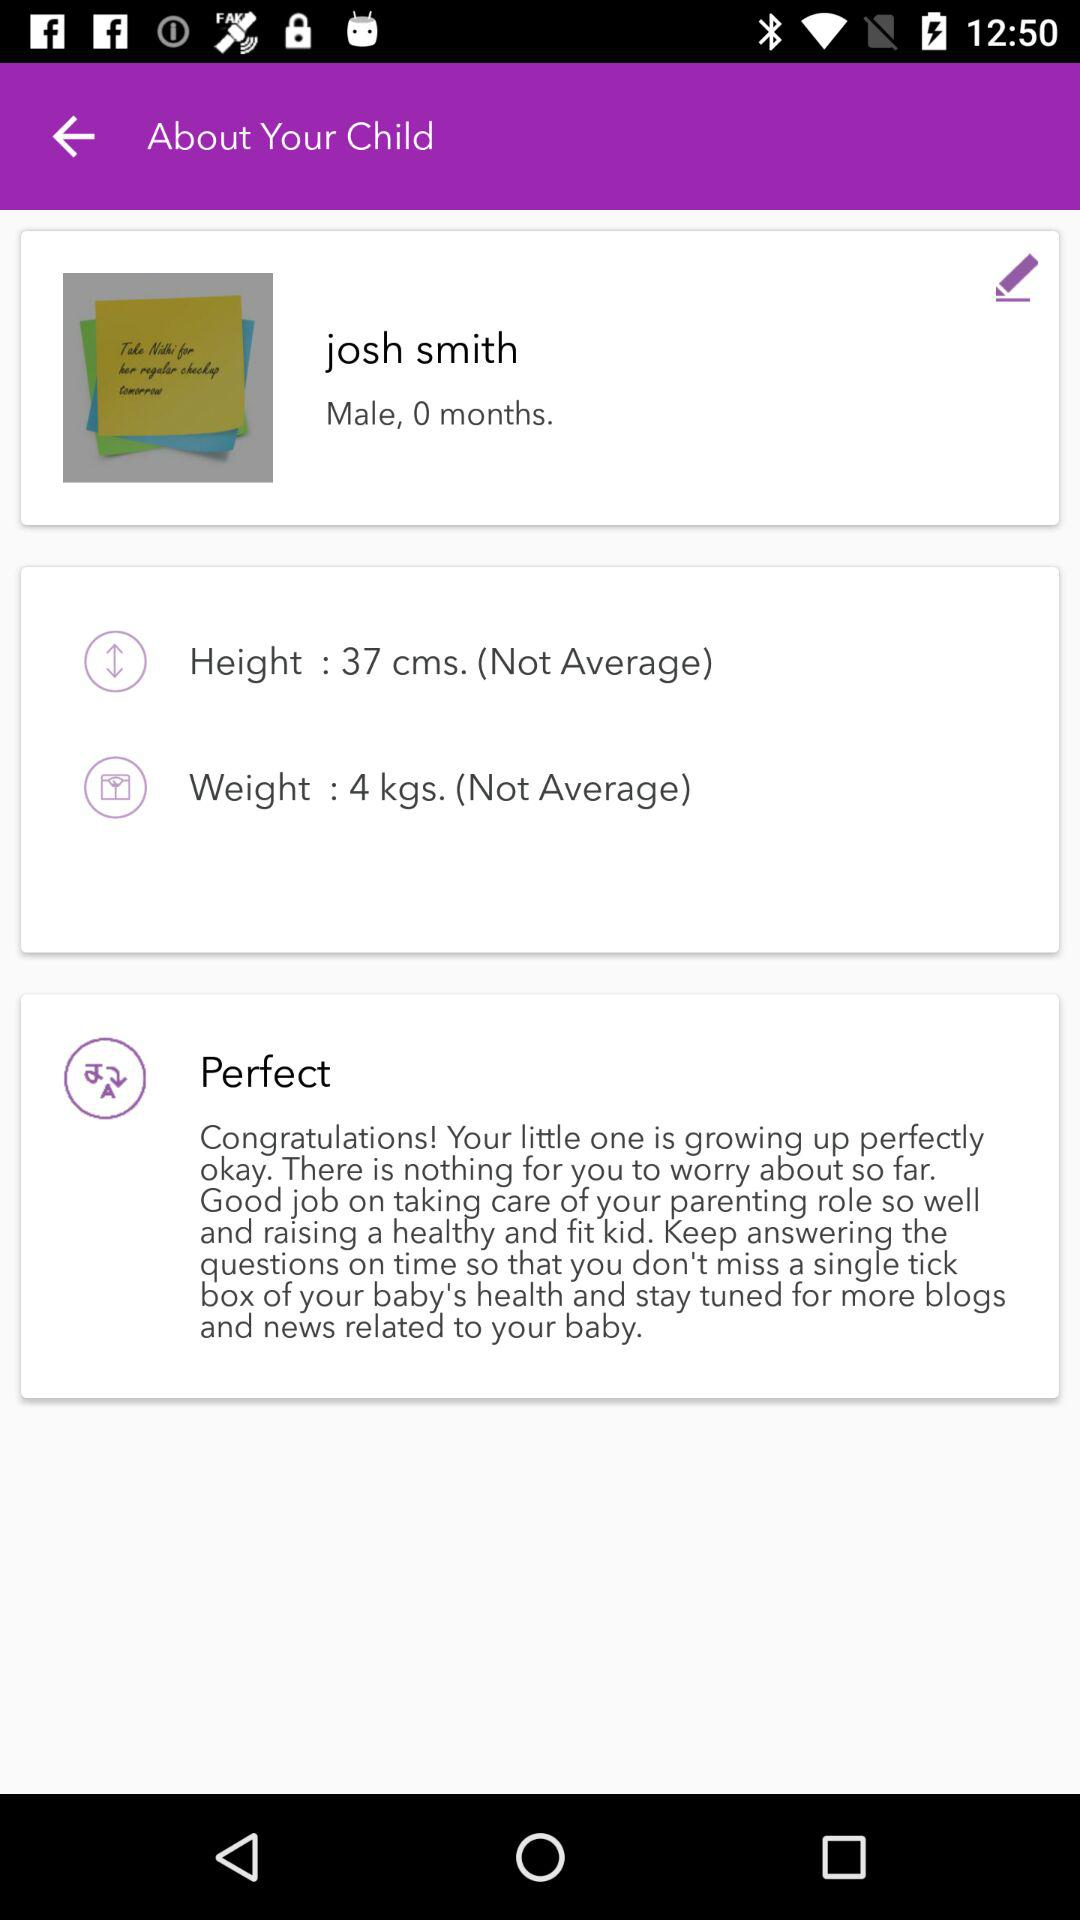What's the gender of the person? The gender of the person is male. 